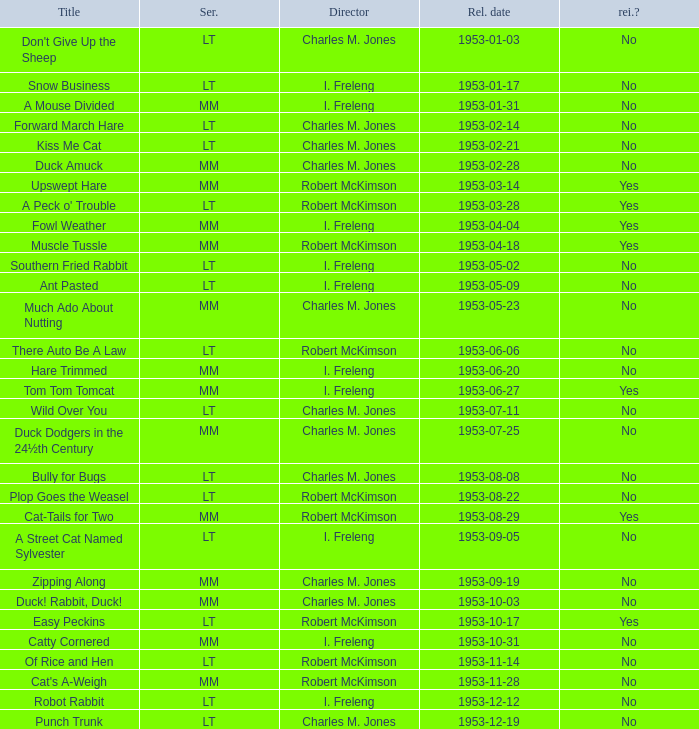What's the series of Kiss Me Cat? LT. 